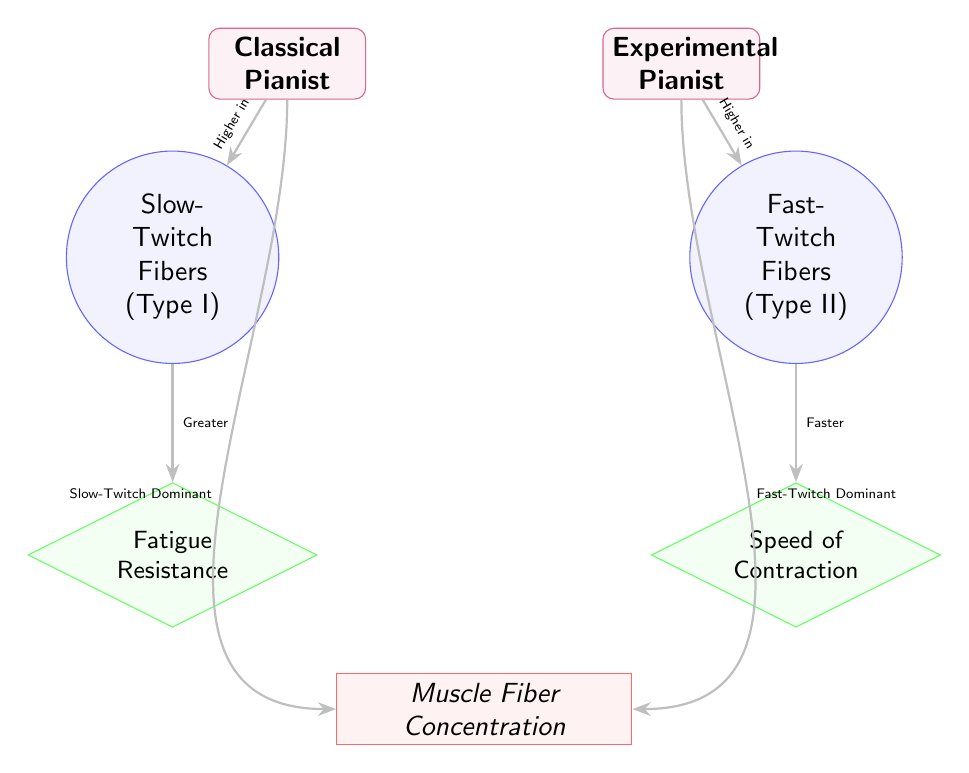What muscle fiber type is considered dominant in classical pianists? The diagram indicates that classical pianists are characterized by a dominance of slow-twitch fibers (Type I), which is explicitly labeled under the "Classical Pianist" category.
Answer: Slow-Twitch Fibers (Type I) What muscle fiber type is considered dominant in experimental pianists? According to the diagram, experimental pianists exhibit a dominance of fast-twitch fibers (Type II), as indicated by the labeling in the "Experimental Pianist" category.
Answer: Fast-Twitch Fibers (Type II) How is fatigue resistance characterized in slow-twitch fibers? The diagram shows that slow-twitch fibers (Type I) are associated with greater fatigue resistance, as denoted by the connection from the slow-twitch fibers to the characteristic node (fatigue resistance).
Answer: Greater How is the speed of contraction characterized in fast-twitch fibers? The diagram illustrates that fast-twitch fibers (Type II) correspond to faster speeds of contraction, which is indicated by the direct relation shown in the diagram from fast-twitch fibers to the speed of contraction node.
Answer: Faster What is the relationship between classical pianists and muscle fiber concentration? The diagram presents a direct relationship showing that classical pianists have a slow-twitch fiber dominance, which leads to a specific muscle fiber concentration, hence indicating a linking relation to the muscle fiber concentration node.
Answer: Slow-Twitch Dominant What is the relationship between experimental pianists and muscle fiber concentration? The diagram indicates that experimental pianists exhibit a fast-twitch fiber dominance, which ties to the concentration of muscle fibers, highlighting a direct relation to the muscle fiber concentration node.
Answer: Fast-Twitch Dominant Which pianist type has a higher concentration of slow-twitch fibers? By analyzing the diagram, it is evident that classical pianists possess a higher concentration of slow-twitch fibers, as depicted in the relationship connecting classical pianists to slow-twitch fibers and ultimately to muscle fiber concentration.
Answer: Classical Pianist Which pianist type has a higher concentration of fast-twitch fibers? The diagram clearly shows that experimental pianists have a higher concentration of fast-twitch fibers, as indicated by the connection established between experimental pianists and fast-twitch fibers, leading to muscle fiber concentration.
Answer: Experimental Pianist 